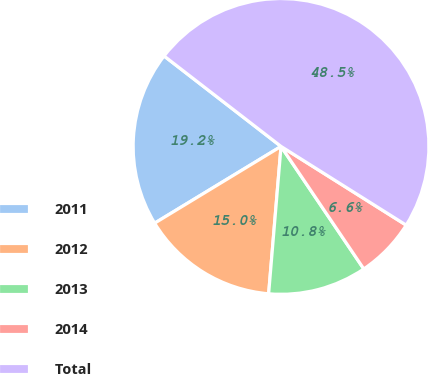Convert chart. <chart><loc_0><loc_0><loc_500><loc_500><pie_chart><fcel>2011<fcel>2012<fcel>2013<fcel>2014<fcel>Total<nl><fcel>19.16%<fcel>14.98%<fcel>10.79%<fcel>6.61%<fcel>48.46%<nl></chart> 